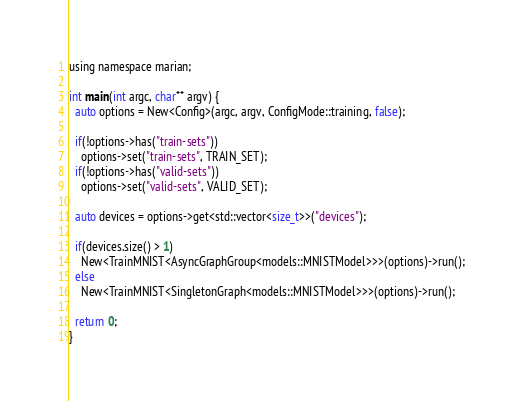<code> <loc_0><loc_0><loc_500><loc_500><_Cuda_>using namespace marian;

int main(int argc, char** argv) {
  auto options = New<Config>(argc, argv, ConfigMode::training, false);

  if(!options->has("train-sets"))
    options->set("train-sets", TRAIN_SET);
  if(!options->has("valid-sets"))
    options->set("valid-sets", VALID_SET);

  auto devices = options->get<std::vector<size_t>>("devices");

  if(devices.size() > 1)
    New<TrainMNIST<AsyncGraphGroup<models::MNISTModel>>>(options)->run();
  else
    New<TrainMNIST<SingletonGraph<models::MNISTModel>>>(options)->run();

  return 0;
}
</code> 